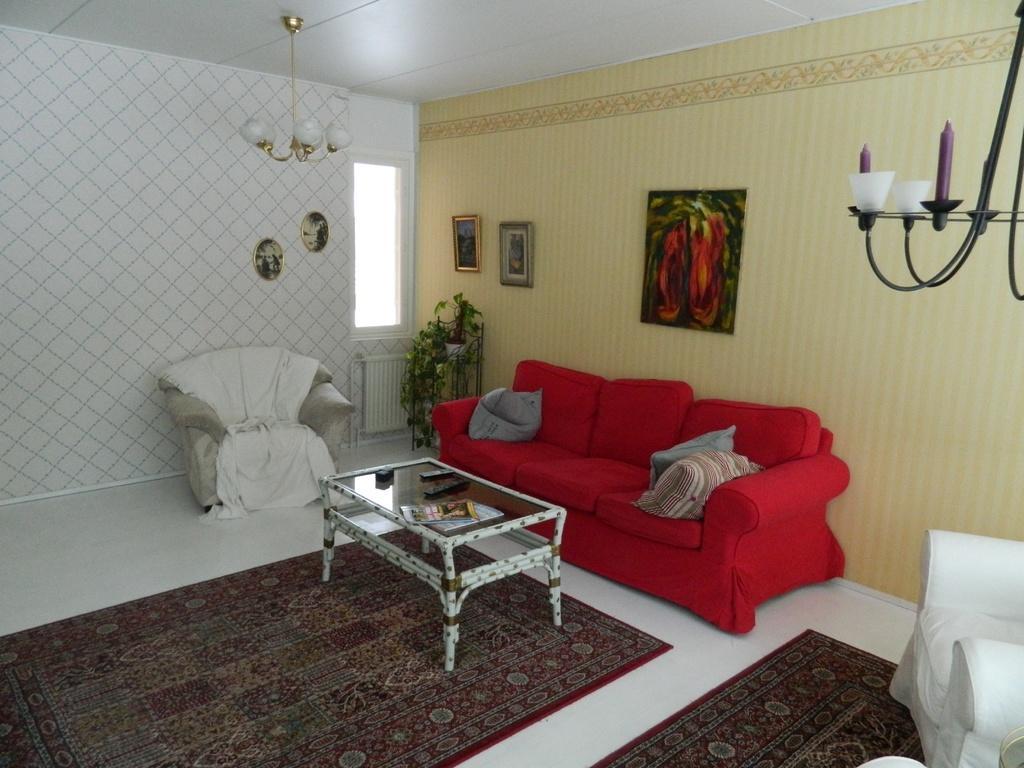Can you describe this image briefly? Here we can see a couch and a couple of chairs present with a table in front of them and we can see carpets on floor and we can see lights and we can see portraits on the walls and we can see plant 